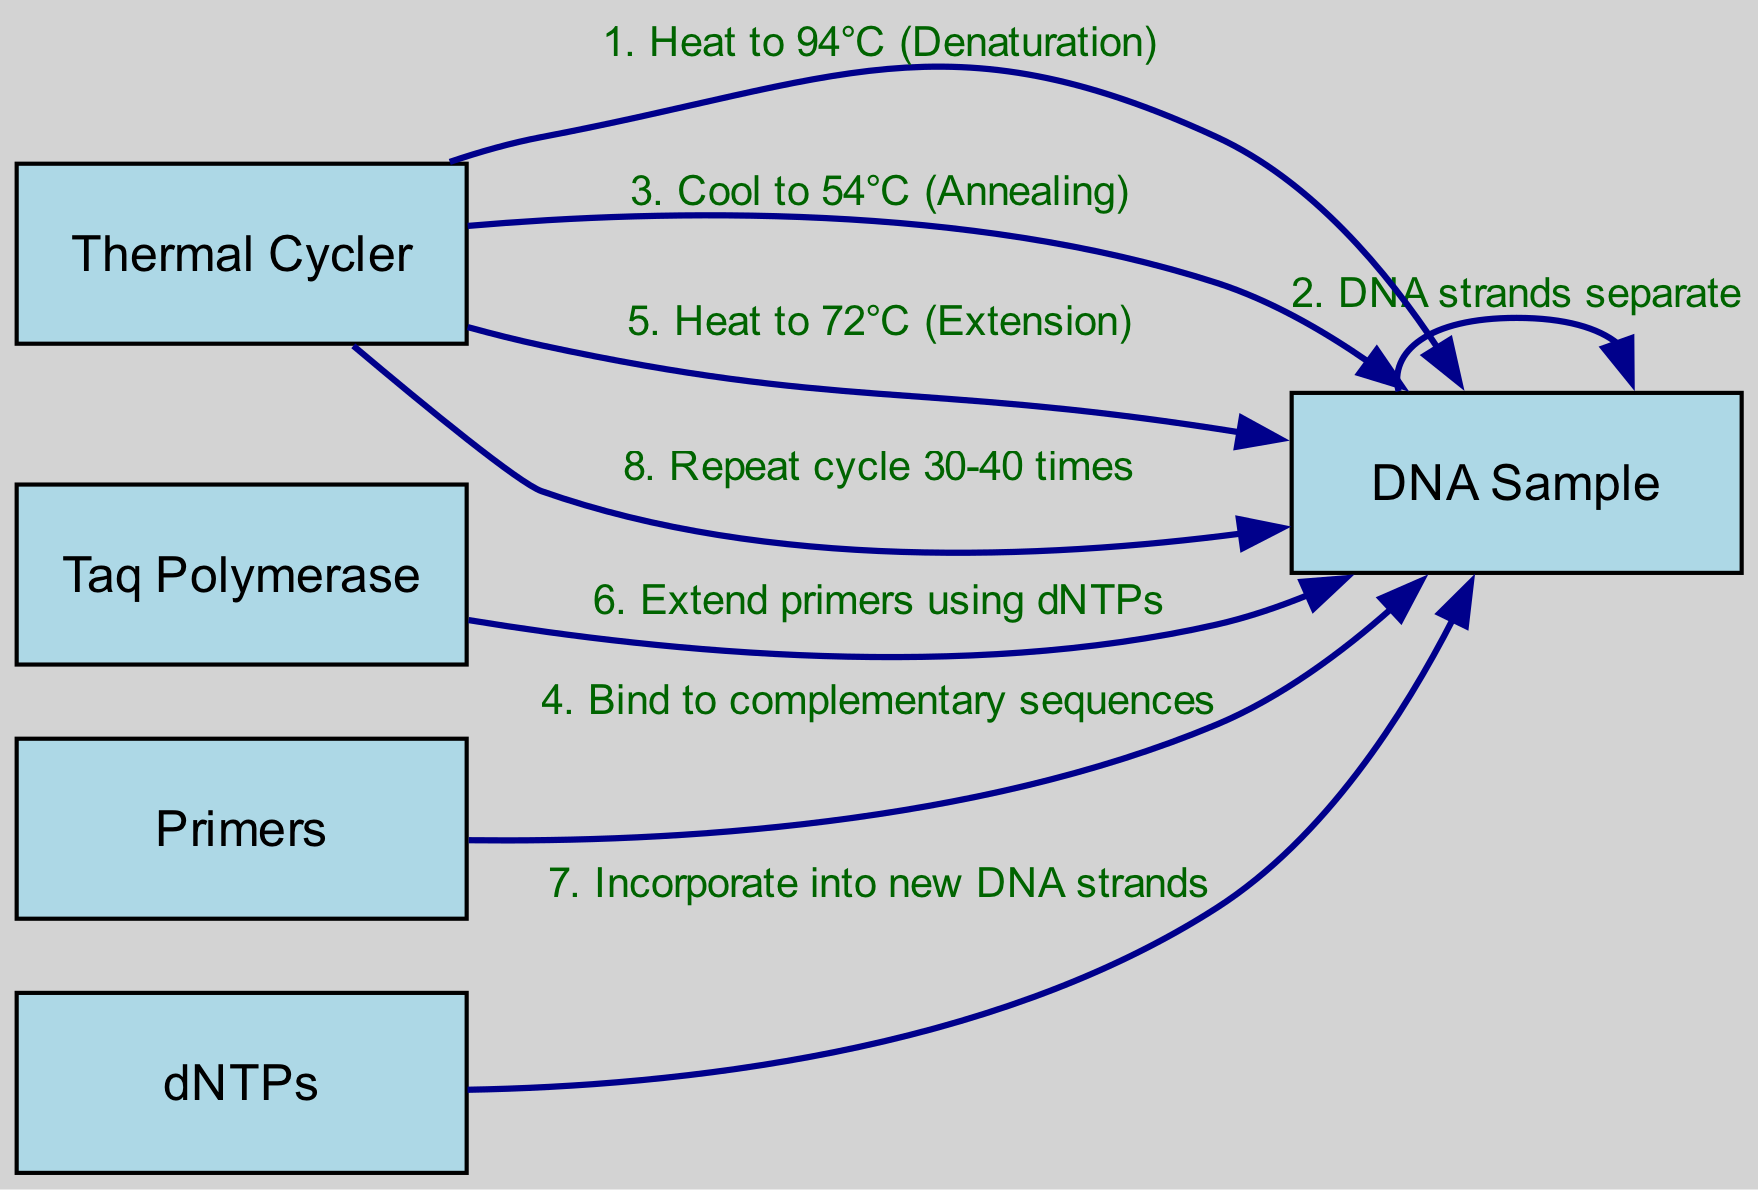What is the first action in the PCR process? The first action in the sequence is initiated by the Thermal Cycler, which heats the DNA Sample to 94°C for denaturation. This can be identified as the first step in the sequence data provided.
Answer: Heat to 94°C (Denaturation) How many main actors are involved in the diagram? The diagram lists five actors: DNA Sample, Thermal Cycler, Taq Polymerase, Primers, and dNTPs. Counting these gives us the total number of main actors.
Answer: 5 What temperature does the thermal cycler cool to for annealing? From the diagram, during the cooling phase, the Thermal Cycler cools the DNA Sample to 54°C for annealing. This temperature is specifically mentioned in the sequence of actions.
Answer: 54°C (Annealing) Which actor incorporates dNTPs into the new DNA strands? The actor responsible for incorporating dNTPs into the new DNA strands is Taq Polymerase. This is derived from the action described in the sequence where Taq Polymerase extends primers using dNTPs.
Answer: Taq Polymerase How many times does the cycle repeat according to the diagram? The diagram specifies that the cycle is repeated 30-40 times. This is mentioned in the last action of the sequence.
Answer: Repeat cycle 30-40 times What happens immediately after the DNA strands separate? Following the separation of DNA strands, the Thermal Cycler then cools the sample to 54°C for annealing. This sequence of actions shows the order clearly.
Answer: Cool to 54°C (Annealing) What do the primers do in the PCR process? The primers bind to complementary sequences on the DNA Sample. This action is explicitly documented in the sequence of events listed within the diagram.
Answer: Bind to complementary sequences Which component provides dNTPs during the extension phase? The component that provides dNTPs is listed as dNTPs in the diagram. They are involved in the action of incorporating them into the new DNA strands.
Answer: dNTPs 